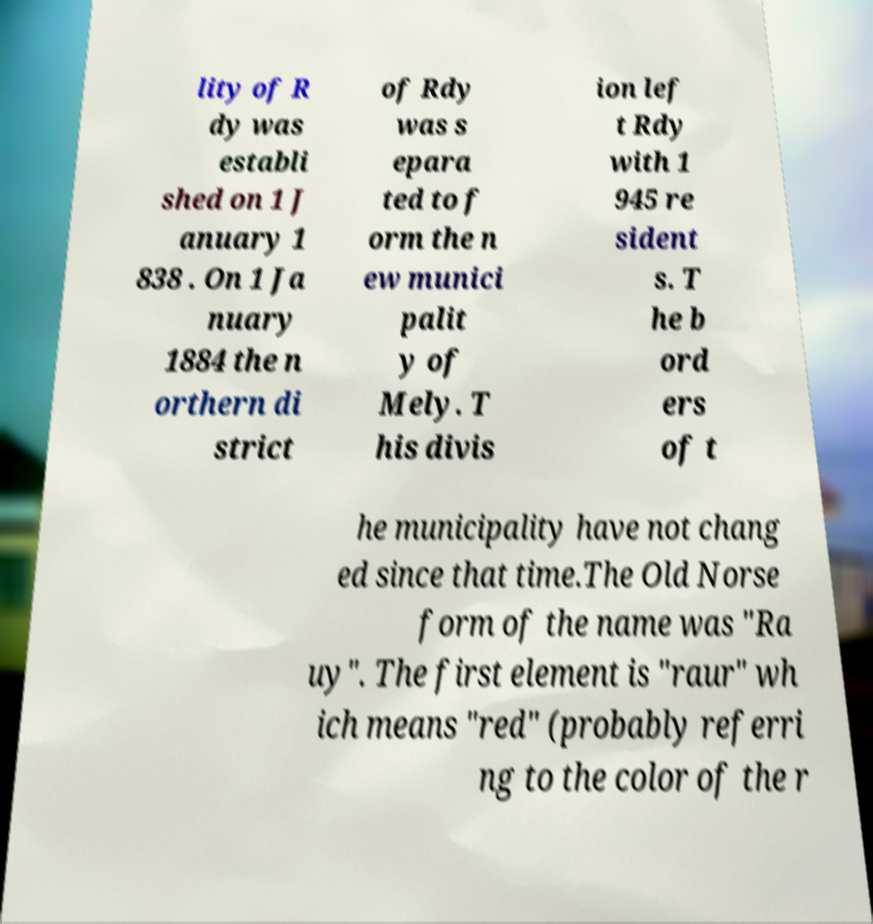Please identify and transcribe the text found in this image. lity of R dy was establi shed on 1 J anuary 1 838 . On 1 Ja nuary 1884 the n orthern di strict of Rdy was s epara ted to f orm the n ew munici palit y of Mely. T his divis ion lef t Rdy with 1 945 re sident s. T he b ord ers of t he municipality have not chang ed since that time.The Old Norse form of the name was "Ra uy". The first element is "raur" wh ich means "red" (probably referri ng to the color of the r 